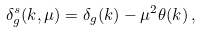Convert formula to latex. <formula><loc_0><loc_0><loc_500><loc_500>\delta _ { g } ^ { s } ( k , \mu ) = \delta _ { g } ( k ) - \mu ^ { 2 } \theta ( k ) \, ,</formula> 